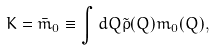<formula> <loc_0><loc_0><loc_500><loc_500>K = { \bar { m } _ { 0 } } \equiv \int d Q \tilde { \rho } ( Q ) m _ { 0 } ( Q ) ,</formula> 